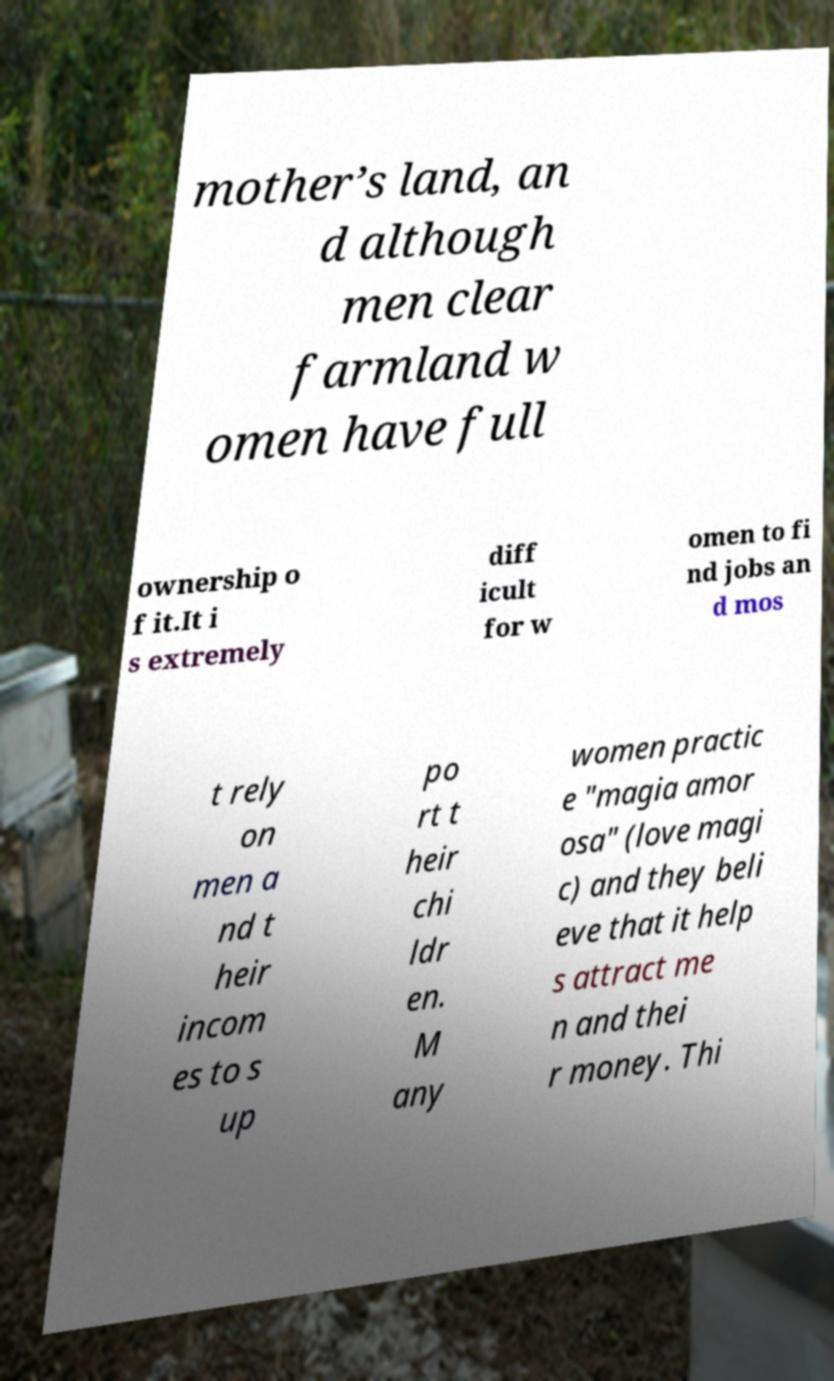Can you accurately transcribe the text from the provided image for me? mother’s land, an d although men clear farmland w omen have full ownership o f it.It i s extremely diff icult for w omen to fi nd jobs an d mos t rely on men a nd t heir incom es to s up po rt t heir chi ldr en. M any women practic e "magia amor osa" (love magi c) and they beli eve that it help s attract me n and thei r money. Thi 